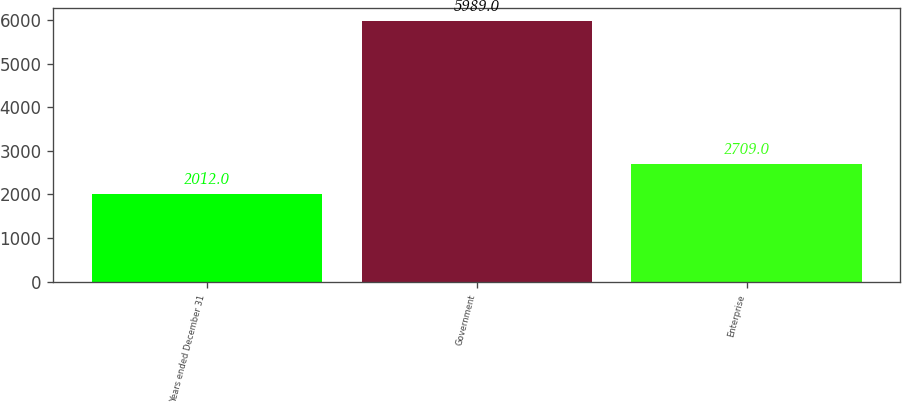<chart> <loc_0><loc_0><loc_500><loc_500><bar_chart><fcel>Years ended December 31<fcel>Government<fcel>Enterprise<nl><fcel>2012<fcel>5989<fcel>2709<nl></chart> 